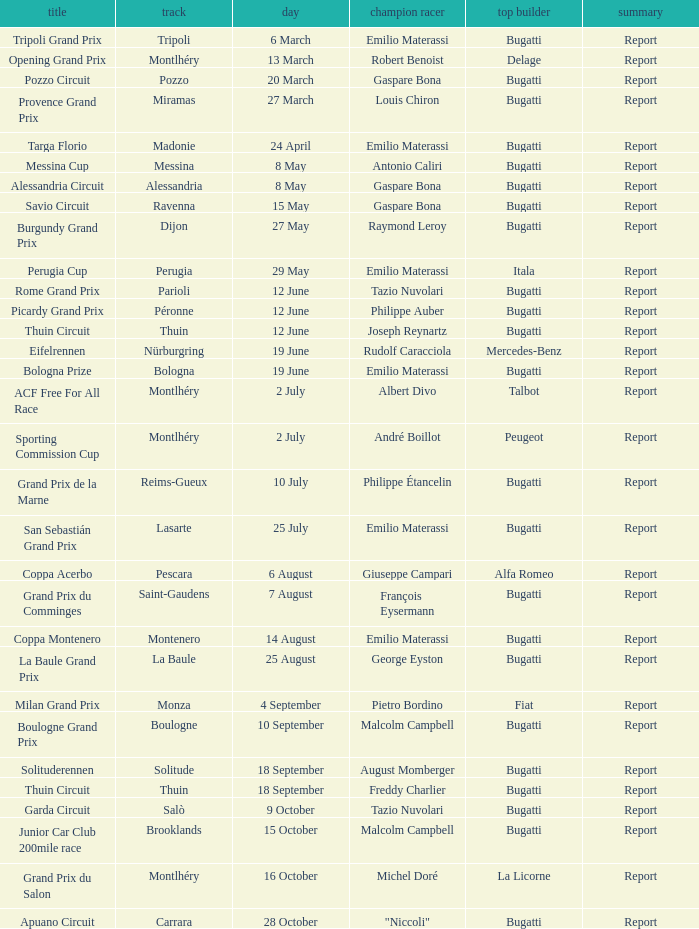Which circuit did françois eysermann win ? Saint-Gaudens. 